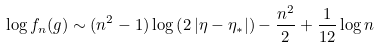<formula> <loc_0><loc_0><loc_500><loc_500>\log f _ { n } ( g ) \sim ( n ^ { 2 } - 1 ) \log \left ( 2 \, | \eta - \eta _ { * } | \right ) - \frac { n ^ { 2 } } { 2 } + \frac { 1 } { 1 2 } \log n</formula> 